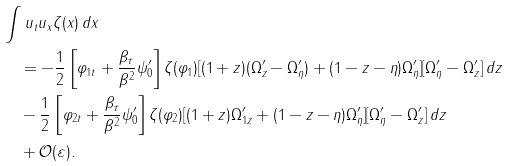Convert formula to latex. <formula><loc_0><loc_0><loc_500><loc_500>& \int u _ { t } u _ { x } \zeta ( x ) \, d x \\ & \quad = - \frac { 1 } { 2 } \left [ \varphi _ { 1 t } + \frac { \beta _ { \tau } } { \beta ^ { 2 } } \psi ^ { \prime } _ { 0 } \right ] \zeta ( \varphi _ { 1 } ) [ ( 1 + z ) ( \Omega ^ { \prime } _ { z } - \Omega ^ { \prime } _ { \eta } ) + ( 1 - z - \eta ) \Omega ^ { \prime } _ { \eta } ] [ \Omega ^ { \prime } _ { \eta } - \Omega ^ { \prime } _ { z } ] \, d z \\ & \quad - \frac { 1 } { 2 } \left [ \varphi _ { 2 t } + \frac { \beta _ { \tau } } { \beta ^ { 2 } } \psi ^ { \prime } _ { 0 } \right ] \zeta ( \varphi _ { 2 } ) [ ( 1 + z ) \Omega ^ { \prime } _ { 1 z } + ( 1 - z - \eta ) \Omega ^ { \prime } _ { \eta } ] [ \Omega ^ { \prime } _ { \eta } - \Omega ^ { \prime } _ { z } ] \, d z \\ & \quad + \mathcal { O } ( \varepsilon ) .</formula> 